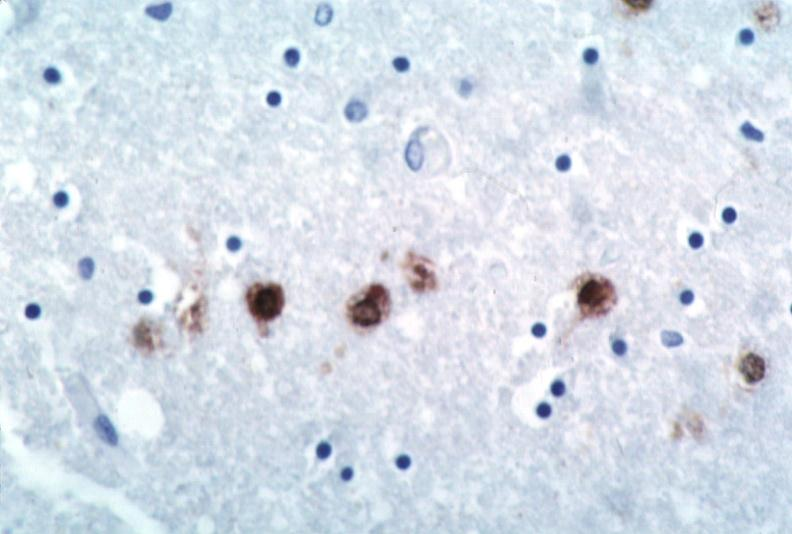what does this image show?
Answer the question using a single word or phrase. Brain 